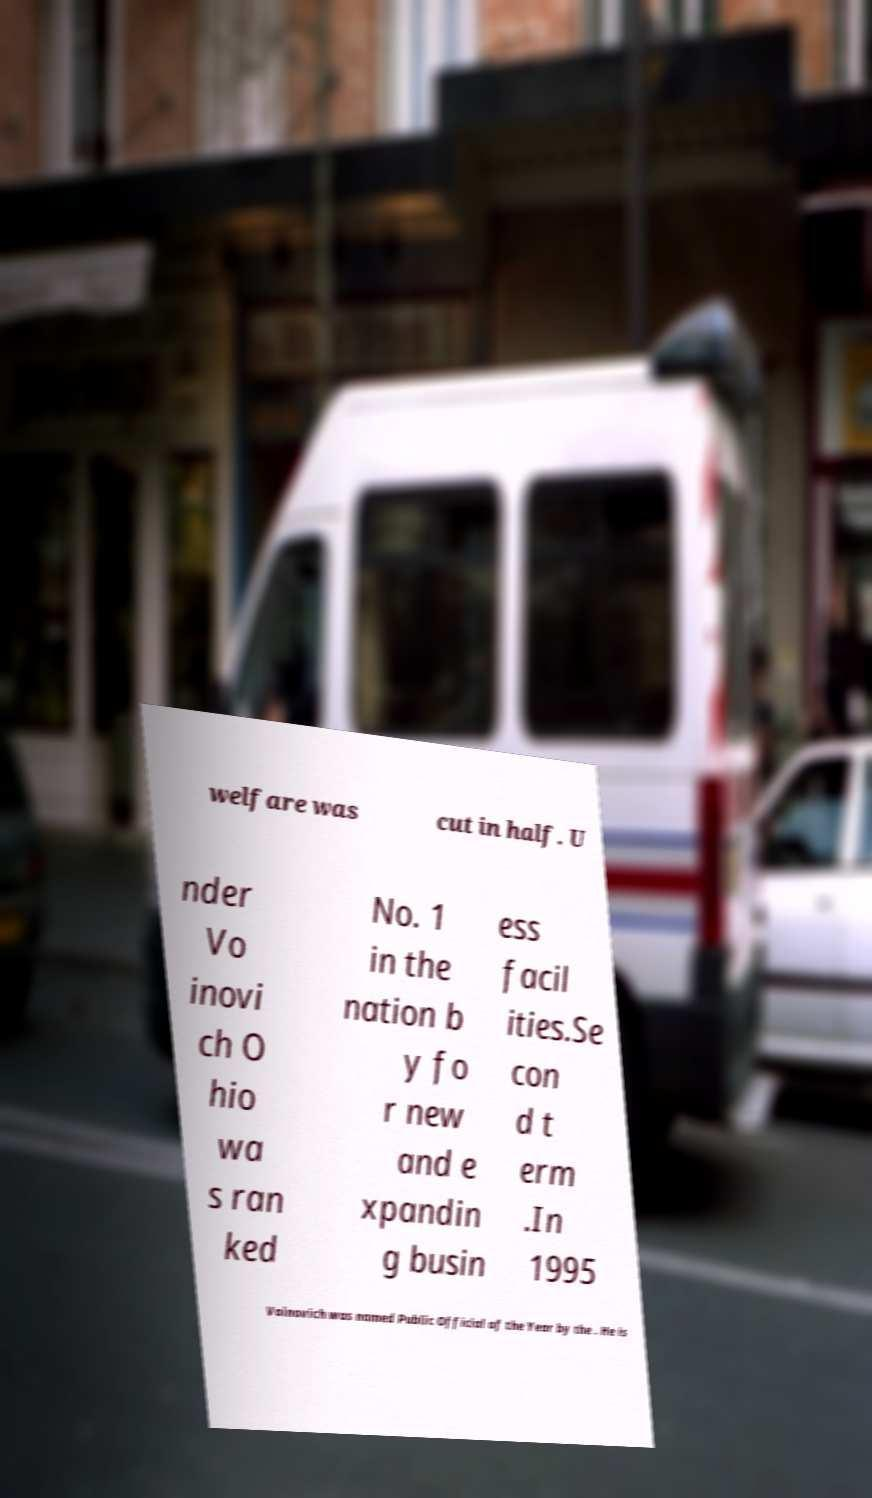I need the written content from this picture converted into text. Can you do that? welfare was cut in half. U nder Vo inovi ch O hio wa s ran ked No. 1 in the nation b y fo r new and e xpandin g busin ess facil ities.Se con d t erm .In 1995 Voinovich was named Public Official of the Year by the . He is 